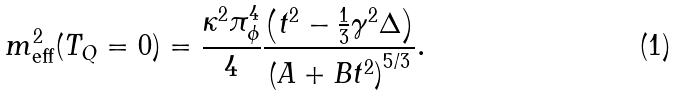Convert formula to latex. <formula><loc_0><loc_0><loc_500><loc_500>m ^ { 2 } _ { \text {eff} } ( T _ { Q } = 0 ) = \frac { \kappa ^ { 2 } \pi ^ { 4 } _ { \phi } } { 4 } \frac { \left ( t ^ { 2 } - \frac { 1 } { 3 } \gamma ^ { 2 } \Delta \right ) } { \left ( A + B t ^ { 2 } \right ) ^ { 5 / 3 } } .</formula> 